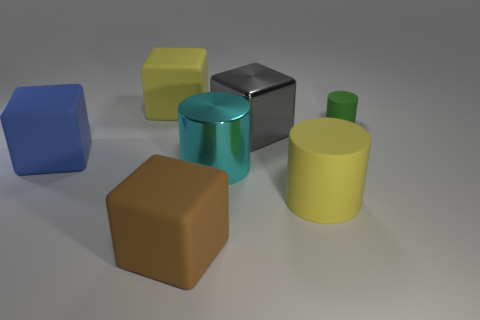Add 2 gray blocks. How many objects exist? 9 Subtract all blocks. How many objects are left? 3 Add 5 tiny yellow rubber things. How many tiny yellow rubber things exist? 5 Subtract 1 brown blocks. How many objects are left? 6 Subtract all brown blocks. Subtract all tiny cylinders. How many objects are left? 5 Add 4 big cylinders. How many big cylinders are left? 6 